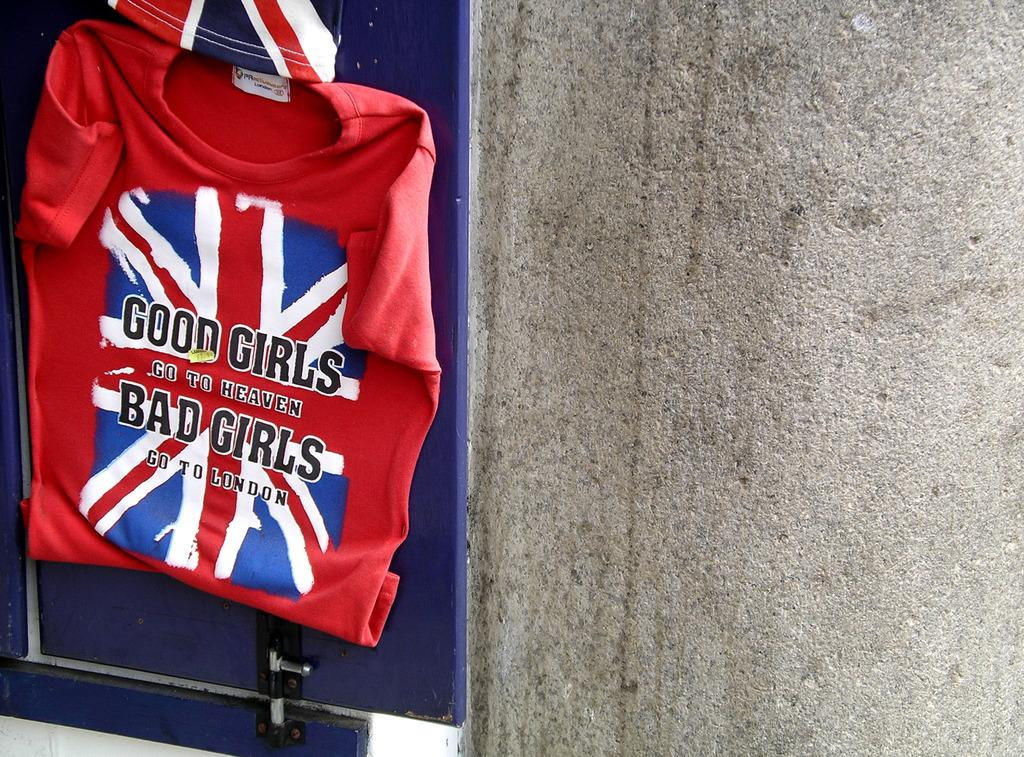<image>
Give a short and clear explanation of the subsequent image. A shirt that says "Good girls go to heaven, bad girls go to London" hangs on a wall. 